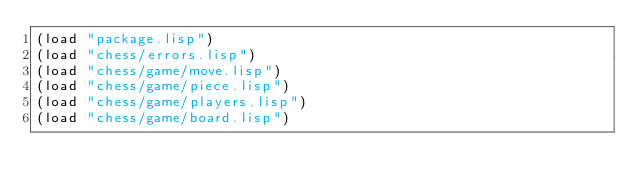<code> <loc_0><loc_0><loc_500><loc_500><_Lisp_>(load "package.lisp")
(load "chess/errors.lisp")
(load "chess/game/move.lisp")
(load "chess/game/piece.lisp")
(load "chess/game/players.lisp")
(load "chess/game/board.lisp")</code> 